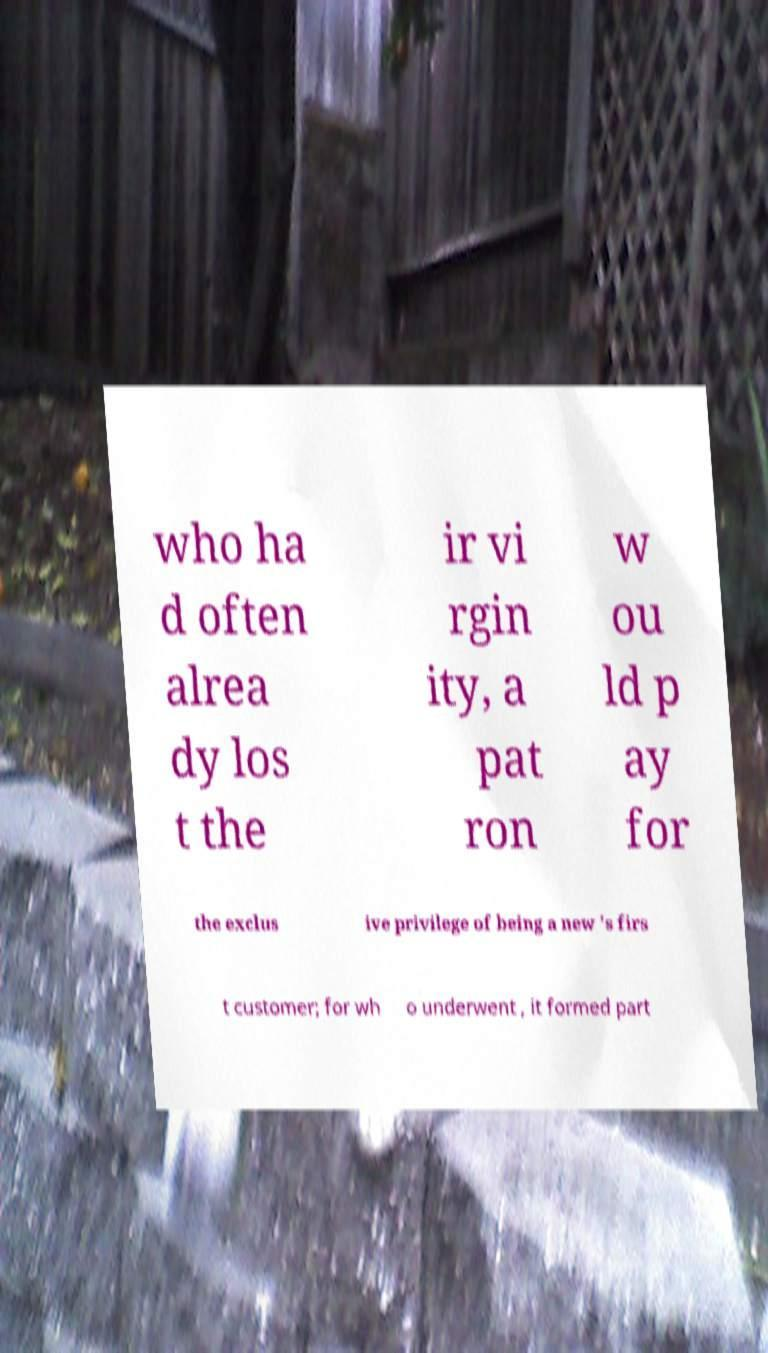Please read and relay the text visible in this image. What does it say? who ha d often alrea dy los t the ir vi rgin ity, a pat ron w ou ld p ay for the exclus ive privilege of being a new 's firs t customer; for wh o underwent , it formed part 